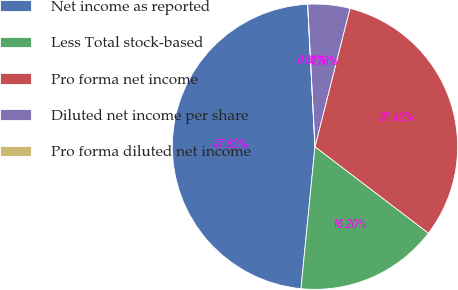<chart> <loc_0><loc_0><loc_500><loc_500><pie_chart><fcel>Net income as reported<fcel>Less Total stock-based<fcel>Pro forma net income<fcel>Diluted net income per share<fcel>Pro forma diluted net income<nl><fcel>47.62%<fcel>16.2%<fcel>31.42%<fcel>4.76%<fcel>0.0%<nl></chart> 